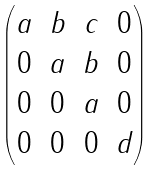Convert formula to latex. <formula><loc_0><loc_0><loc_500><loc_500>\begin{pmatrix} a & b & c & 0 \\ 0 & a & b & 0 \\ 0 & 0 & a & 0 \\ 0 & 0 & 0 & d \end{pmatrix}</formula> 